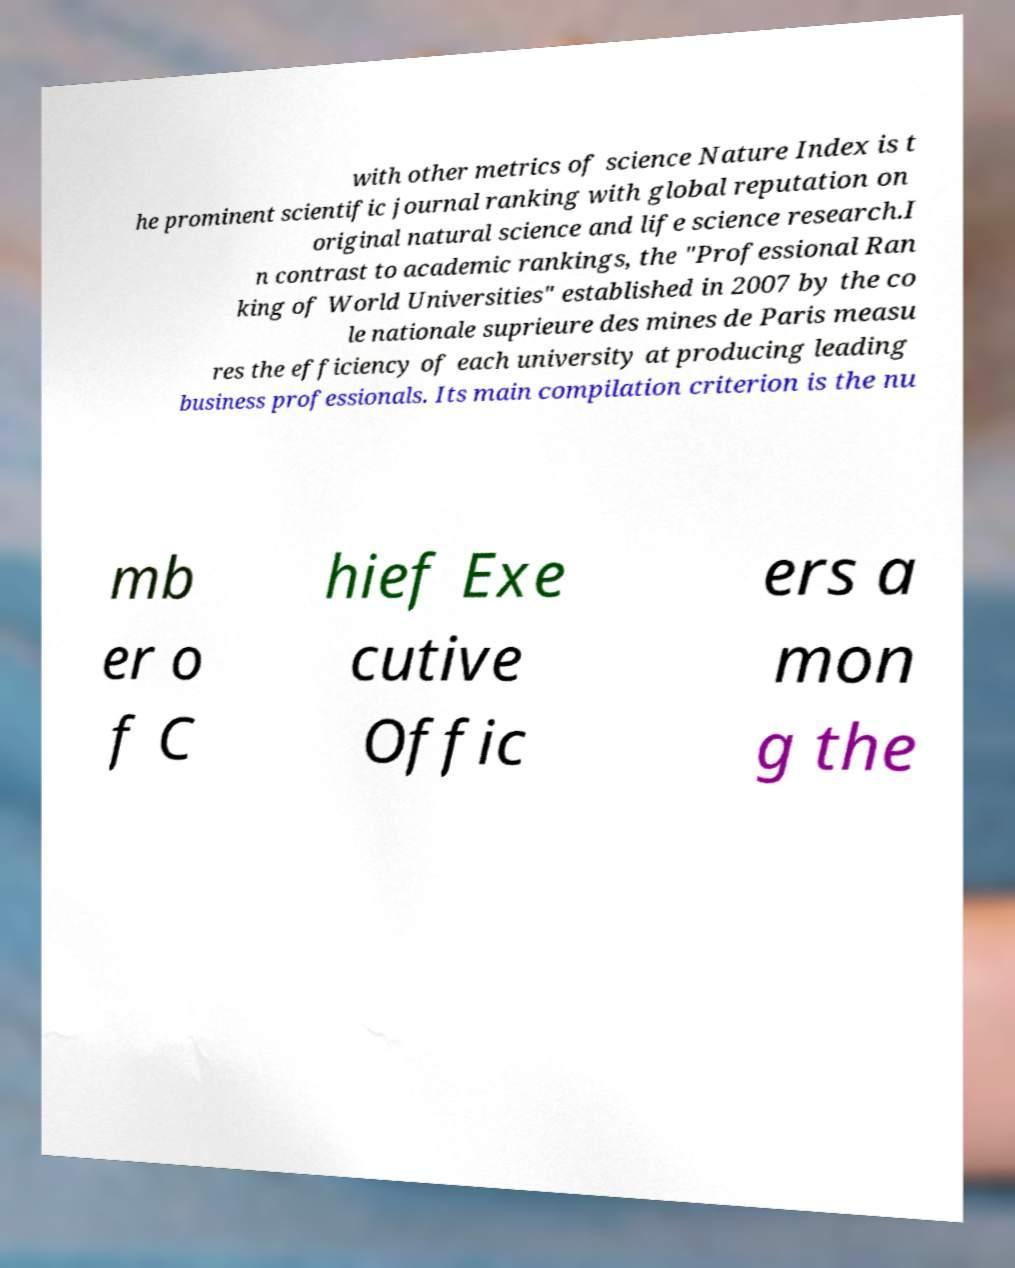Please identify and transcribe the text found in this image. with other metrics of science Nature Index is t he prominent scientific journal ranking with global reputation on original natural science and life science research.I n contrast to academic rankings, the "Professional Ran king of World Universities" established in 2007 by the co le nationale suprieure des mines de Paris measu res the efficiency of each university at producing leading business professionals. Its main compilation criterion is the nu mb er o f C hief Exe cutive Offic ers a mon g the 